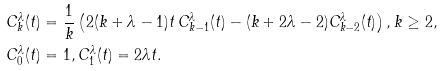<formula> <loc_0><loc_0><loc_500><loc_500>C ^ { \lambda } _ { k } ( t ) & = \frac { 1 } { k } \left ( 2 ( k + \lambda - 1 ) t \, C ^ { \lambda } _ { k - 1 } ( t ) - ( k + 2 \lambda - 2 ) C ^ { \lambda } _ { k - 2 } ( t ) \right ) , k \geq 2 , \\ C ^ { \lambda } _ { 0 } ( t ) & = 1 , C ^ { \lambda } _ { 1 } ( t ) = 2 \lambda t .</formula> 